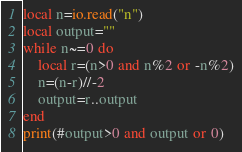Convert code to text. <code><loc_0><loc_0><loc_500><loc_500><_Lua_>local n=io.read("n")
local output=""
while n~=0 do
    local r=(n>0 and n%2 or -n%2)
    n=(n-r)//-2
    output=r..output
end
print(#output>0 and output or 0)</code> 